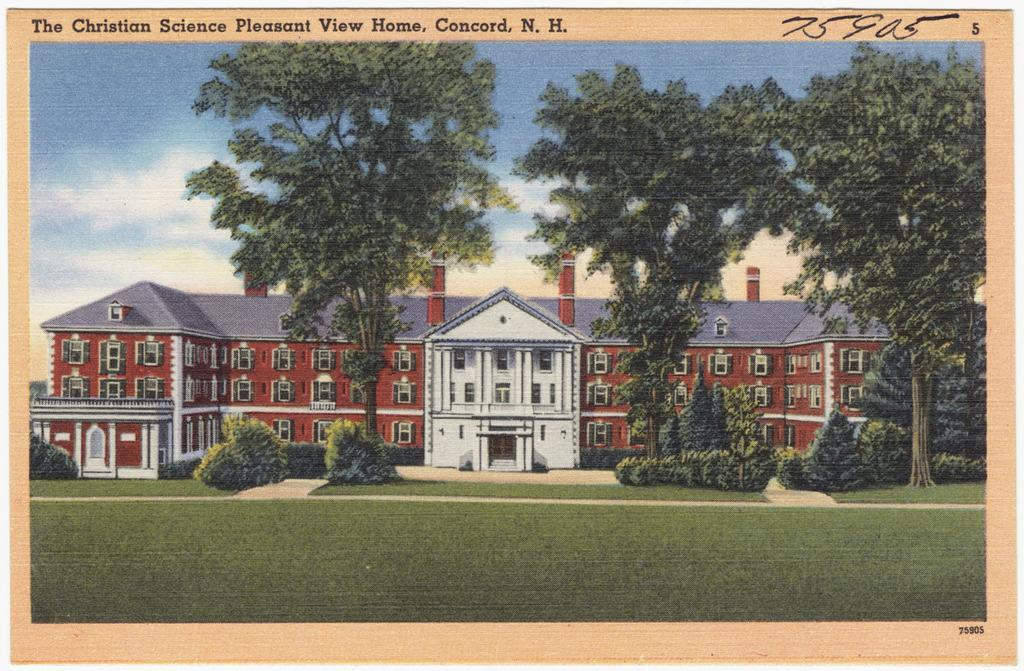What type of outdoor area is visible in the image? There is a garden in the image. What type of vegetation can be seen in the garden? There are trees in the image. What type of structure is present in the image? There is a big building in the image. How many windows are visible on the building? The building has multiple windows. How can someone enter the building in the image? There is an access point to enter the building in the image. What type of noise can be heard coming from the trees in the image? There is no indication of any noise in the image, as it only shows a garden, trees, a big building, and an access point to enter the building. What shape is the ice in the image? There is no ice present in the image. 